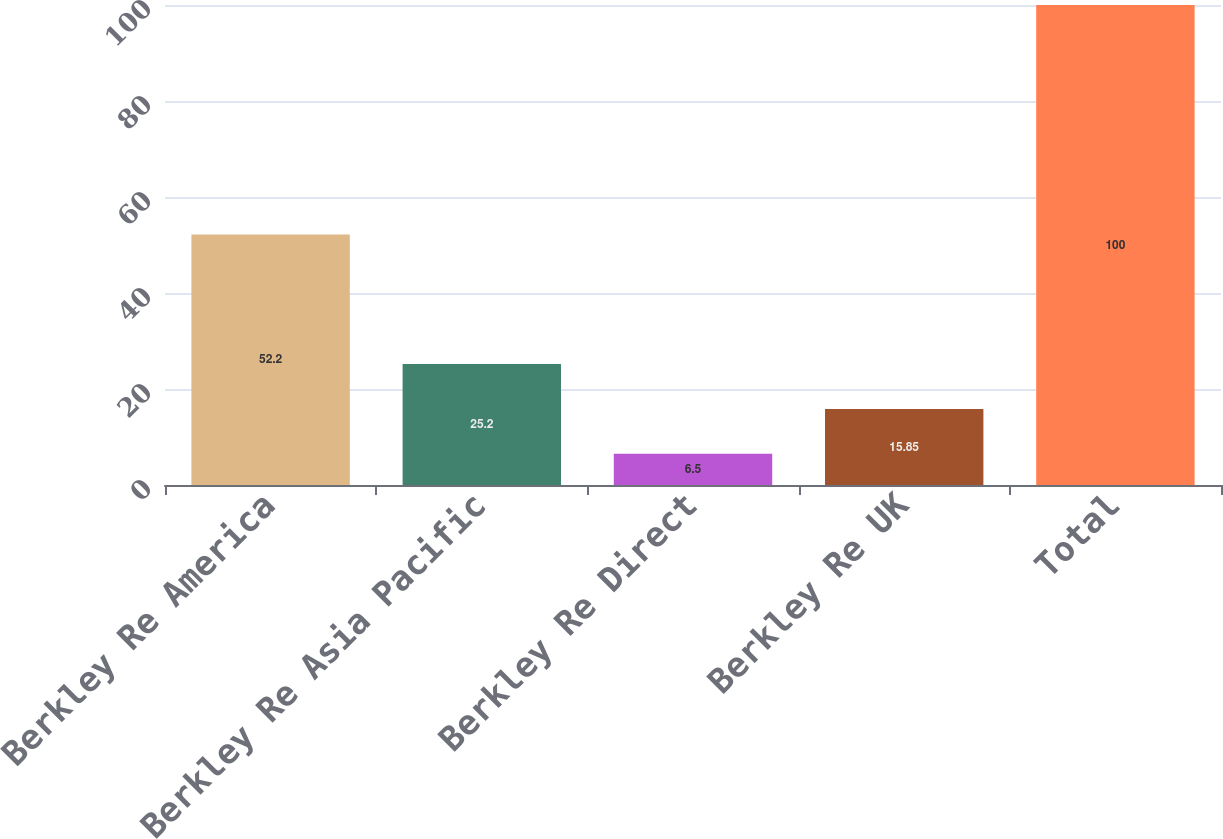Convert chart to OTSL. <chart><loc_0><loc_0><loc_500><loc_500><bar_chart><fcel>Berkley Re America<fcel>Berkley Re Asia Pacific<fcel>Berkley Re Direct<fcel>Berkley Re UK<fcel>Total<nl><fcel>52.2<fcel>25.2<fcel>6.5<fcel>15.85<fcel>100<nl></chart> 